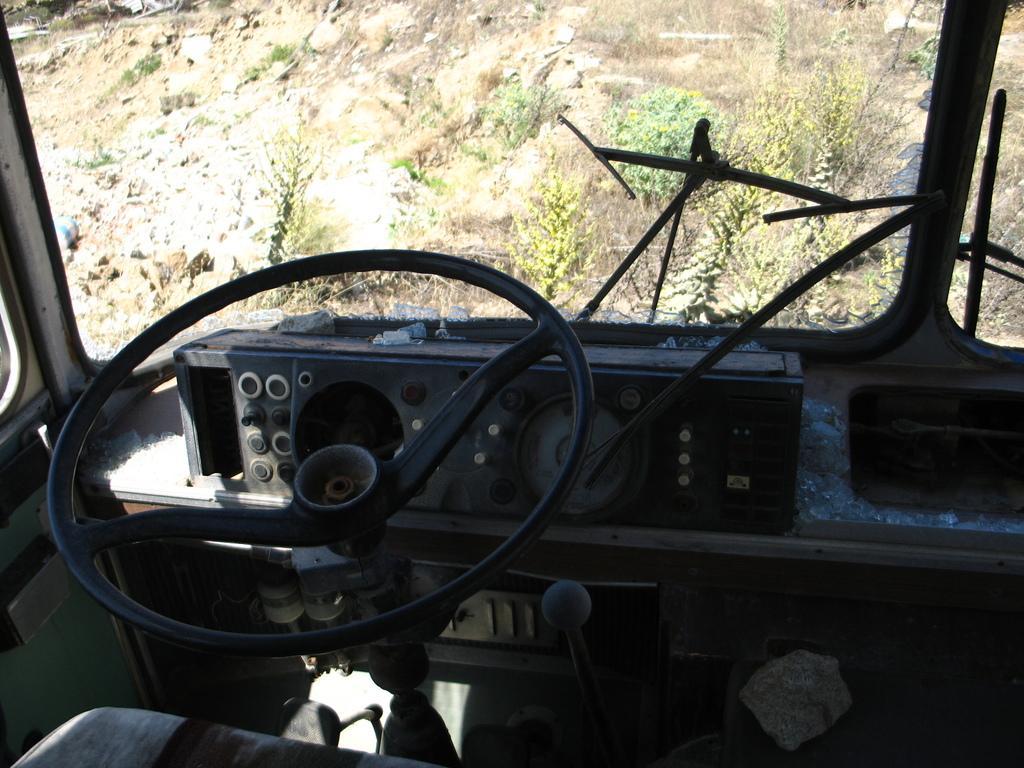Can you describe this image briefly? This picture is clicked inside the vehicle. In this picture, we see a steering wheel, dashboard and a seat. In front of that, we see wipers and a front glass from which we can see trees and rocks. 